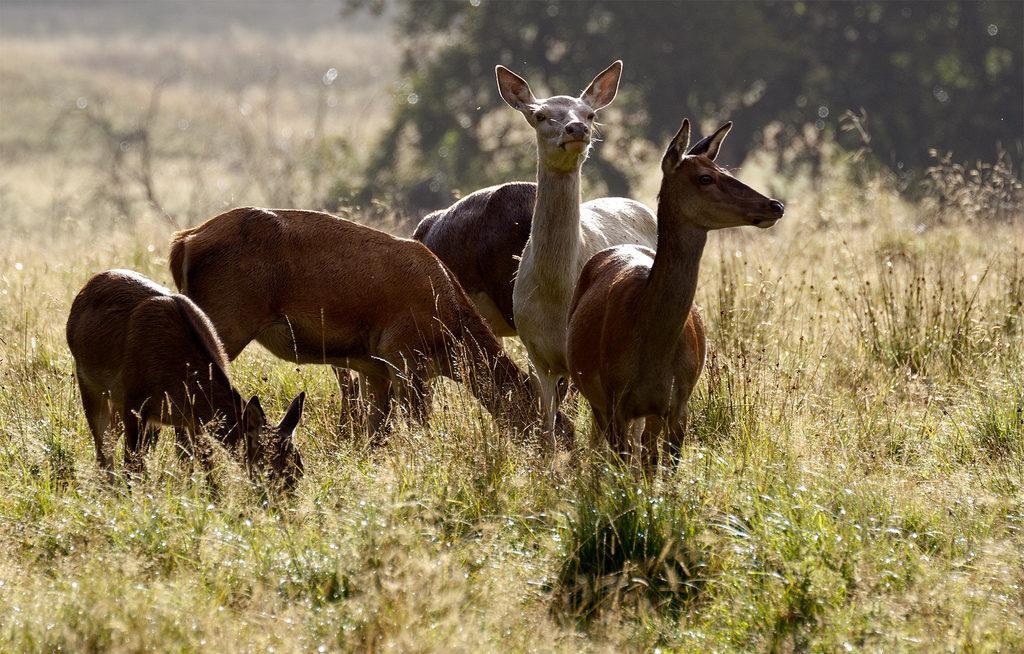Could you give a brief overview of what you see in this image? In this image there are five deers present in the grass. There is also a tree in the top. 